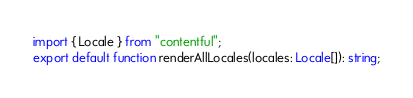Convert code to text. <code><loc_0><loc_0><loc_500><loc_500><_TypeScript_>import { Locale } from "contentful";
export default function renderAllLocales(locales: Locale[]): string;
</code> 